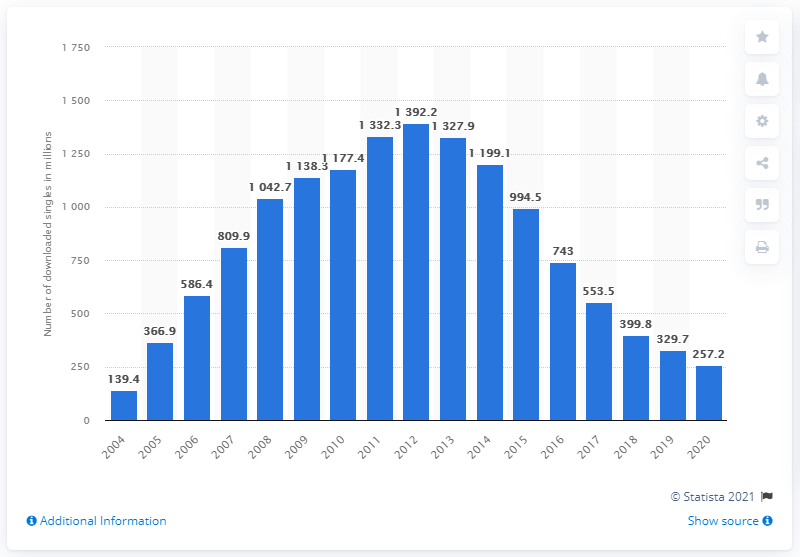Outline some significant characteristics in this image. In the year 2020, a total of 257,200 digital music singles were downloaded in the United States. In 2015, there were 329.7 million digital single downloads. In the previous year, a total of 329.7 digital music singles were downloaded in the United States. 